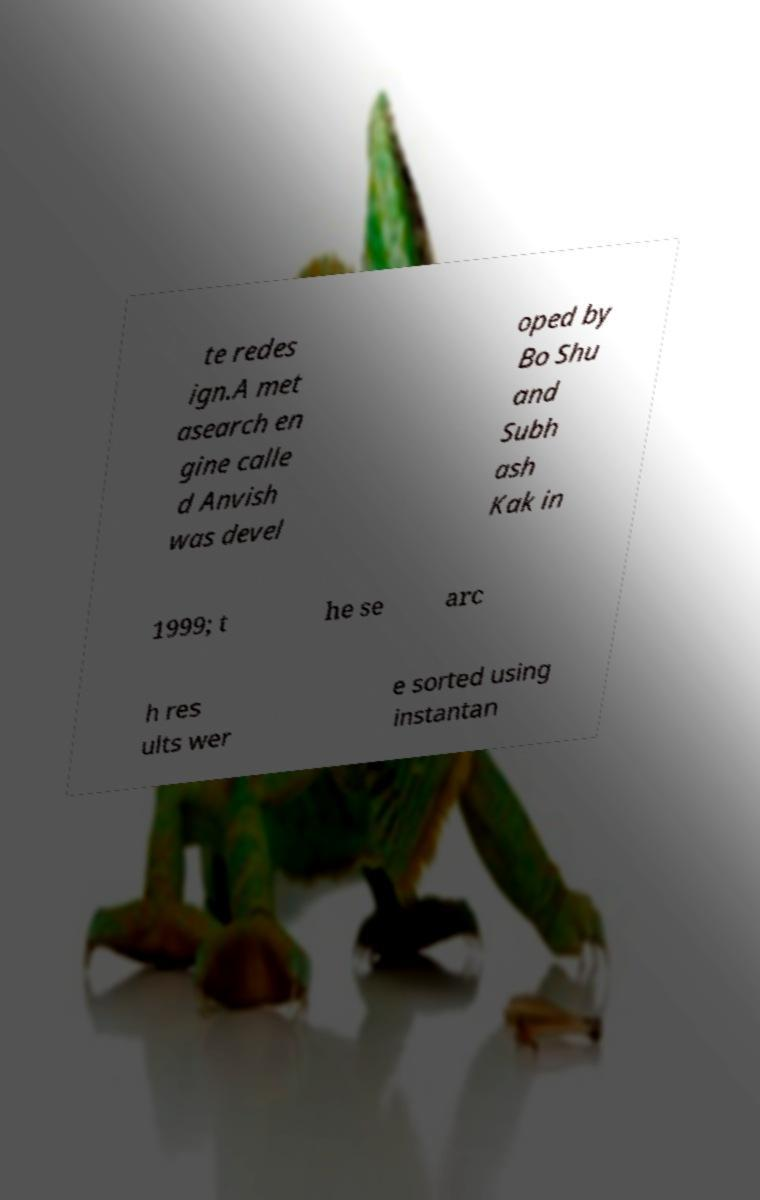Could you assist in decoding the text presented in this image and type it out clearly? te redes ign.A met asearch en gine calle d Anvish was devel oped by Bo Shu and Subh ash Kak in 1999; t he se arc h res ults wer e sorted using instantan 